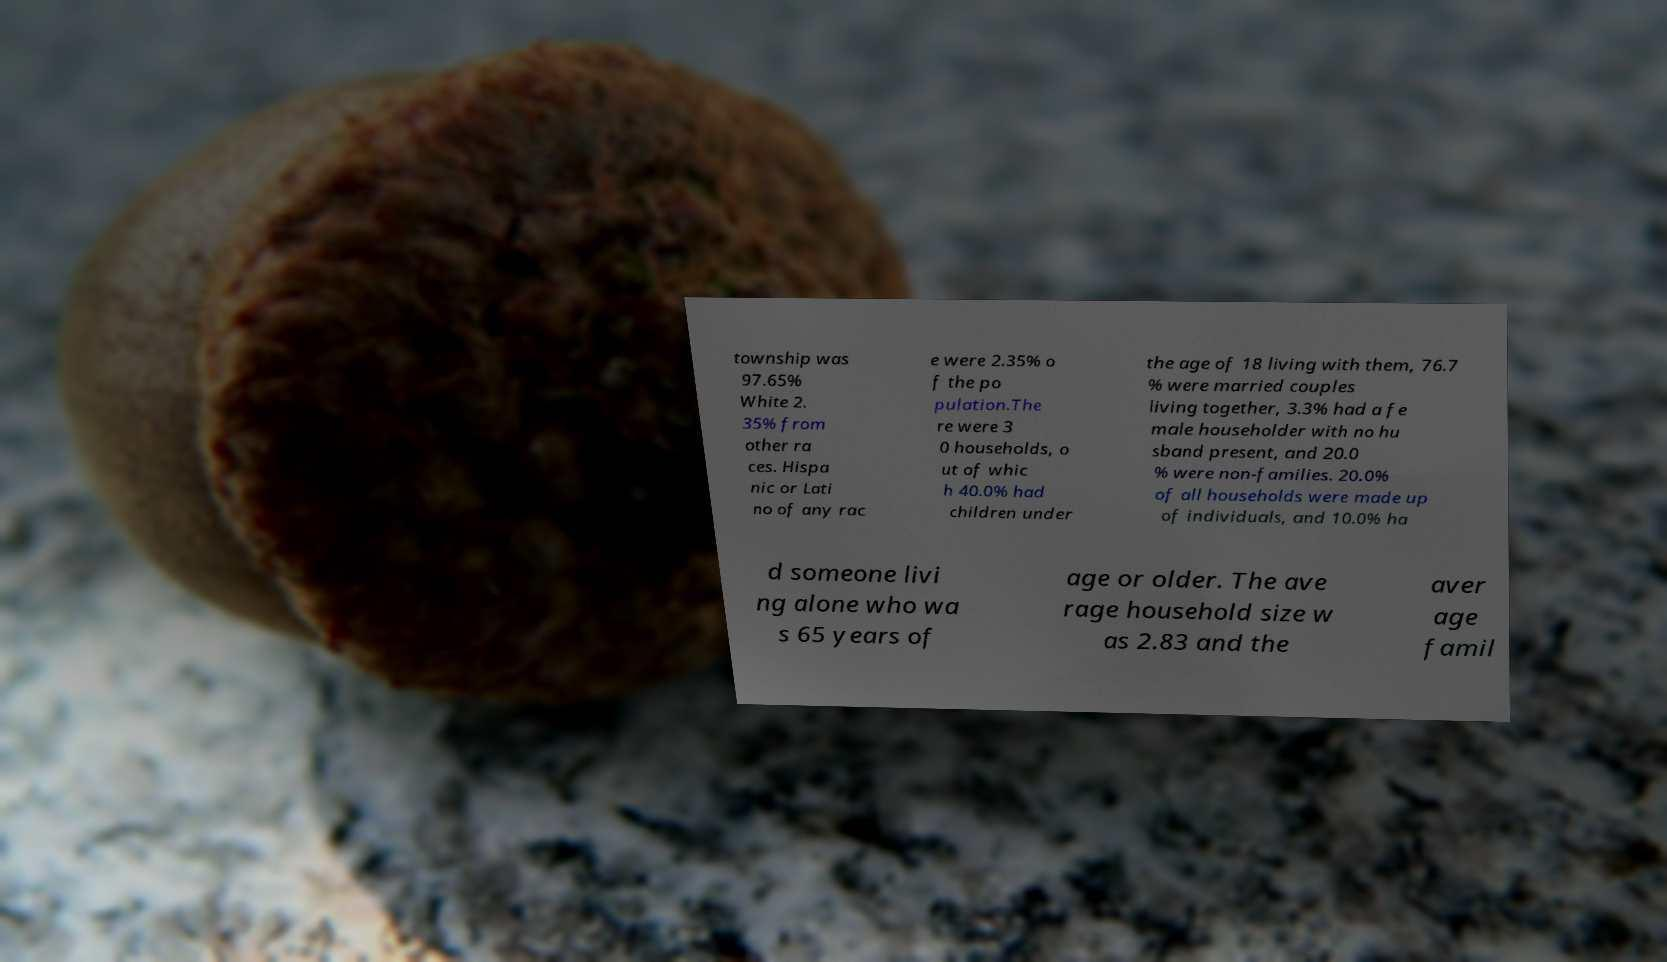Could you extract and type out the text from this image? township was 97.65% White 2. 35% from other ra ces. Hispa nic or Lati no of any rac e were 2.35% o f the po pulation.The re were 3 0 households, o ut of whic h 40.0% had children under the age of 18 living with them, 76.7 % were married couples living together, 3.3% had a fe male householder with no hu sband present, and 20.0 % were non-families. 20.0% of all households were made up of individuals, and 10.0% ha d someone livi ng alone who wa s 65 years of age or older. The ave rage household size w as 2.83 and the aver age famil 